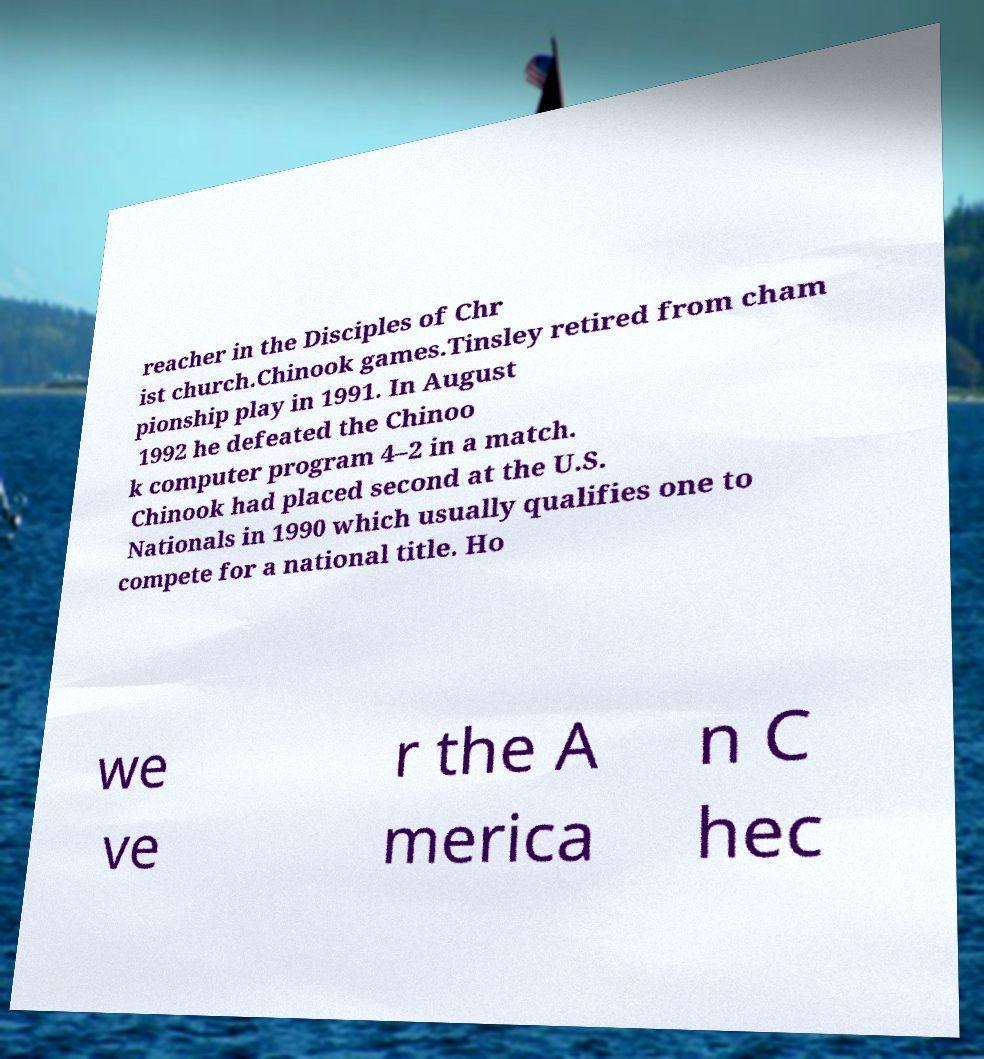Could you extract and type out the text from this image? reacher in the Disciples of Chr ist church.Chinook games.Tinsley retired from cham pionship play in 1991. In August 1992 he defeated the Chinoo k computer program 4–2 in a match. Chinook had placed second at the U.S. Nationals in 1990 which usually qualifies one to compete for a national title. Ho we ve r the A merica n C hec 